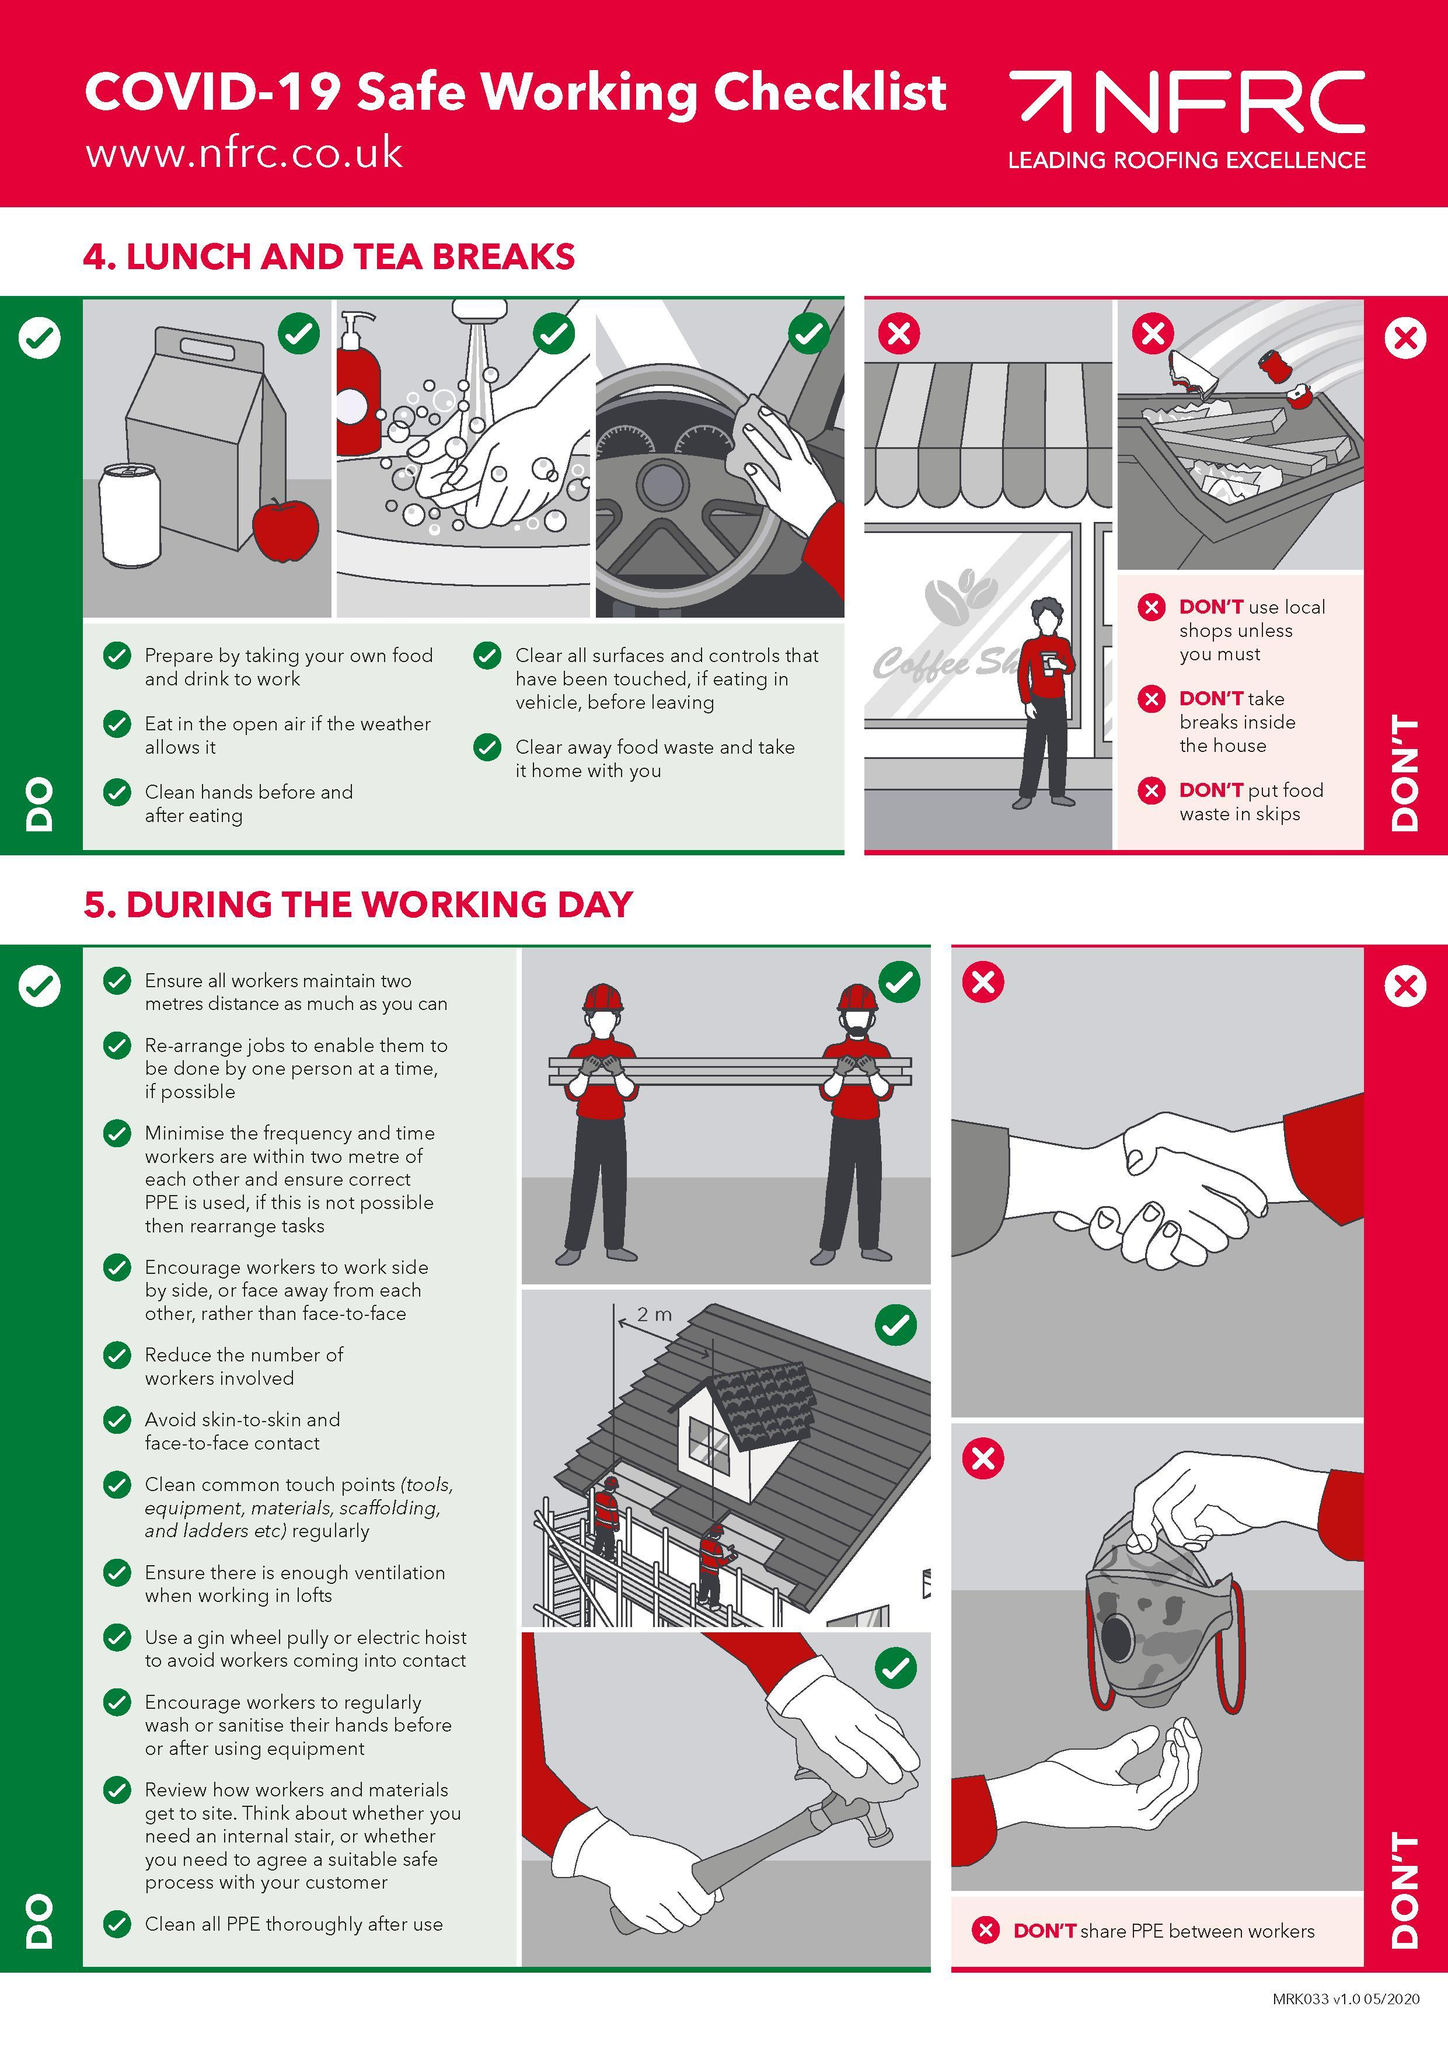How many images for Do's are listed in the infographic under the heading "Lunch and Tea Breaks"?
Answer the question with a short phrase. 3 What is the second Don't listed in the infographic? Don't take breaks inside the house How many images for Do's are listed in the infographic under the heading "During the working day"? 3 What is the DON'T mentioned under the heading "During the working day"? DON'T share PPE between workers What is the third DON'T listed in the infographic? DON'T put food waste in skips 